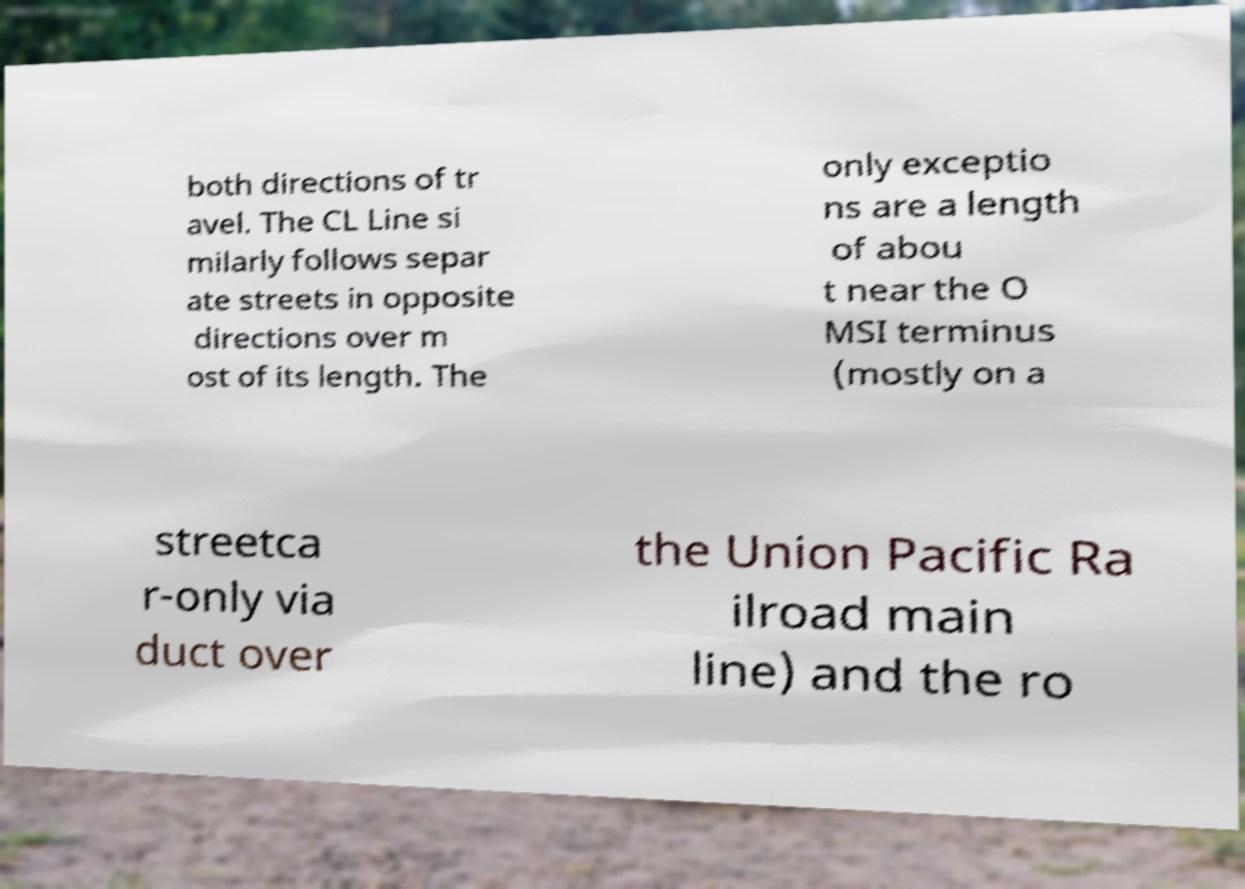What messages or text are displayed in this image? I need them in a readable, typed format. both directions of tr avel. The CL Line si milarly follows separ ate streets in opposite directions over m ost of its length. The only exceptio ns are a length of abou t near the O MSI terminus (mostly on a streetca r-only via duct over the Union Pacific Ra ilroad main line) and the ro 